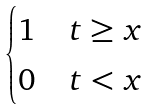Convert formula to latex. <formula><loc_0><loc_0><loc_500><loc_500>\begin{cases} 1 & t \geq x \\ 0 & t < x \end{cases}</formula> 